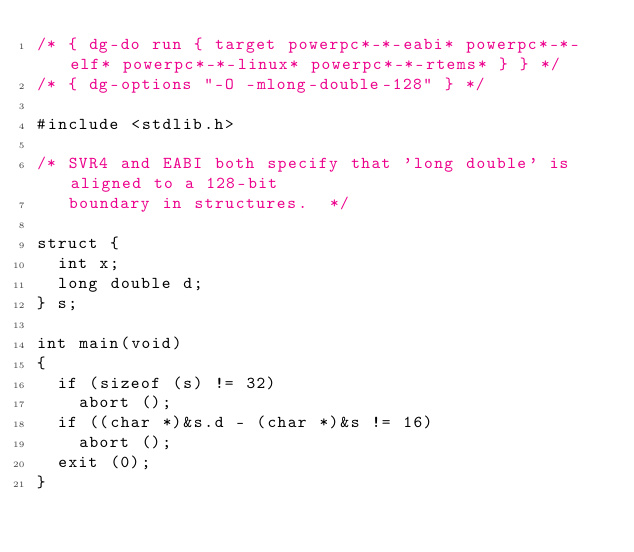Convert code to text. <code><loc_0><loc_0><loc_500><loc_500><_C_>/* { dg-do run { target powerpc*-*-eabi* powerpc*-*-elf* powerpc*-*-linux* powerpc*-*-rtems* } } */
/* { dg-options "-O -mlong-double-128" } */

#include <stdlib.h>

/* SVR4 and EABI both specify that 'long double' is aligned to a 128-bit
   boundary in structures.  */

struct {
  int x;
  long double d;
} s;

int main(void)
{
  if (sizeof (s) != 32)
    abort ();
  if ((char *)&s.d - (char *)&s != 16)
    abort ();
  exit (0);
}
</code> 